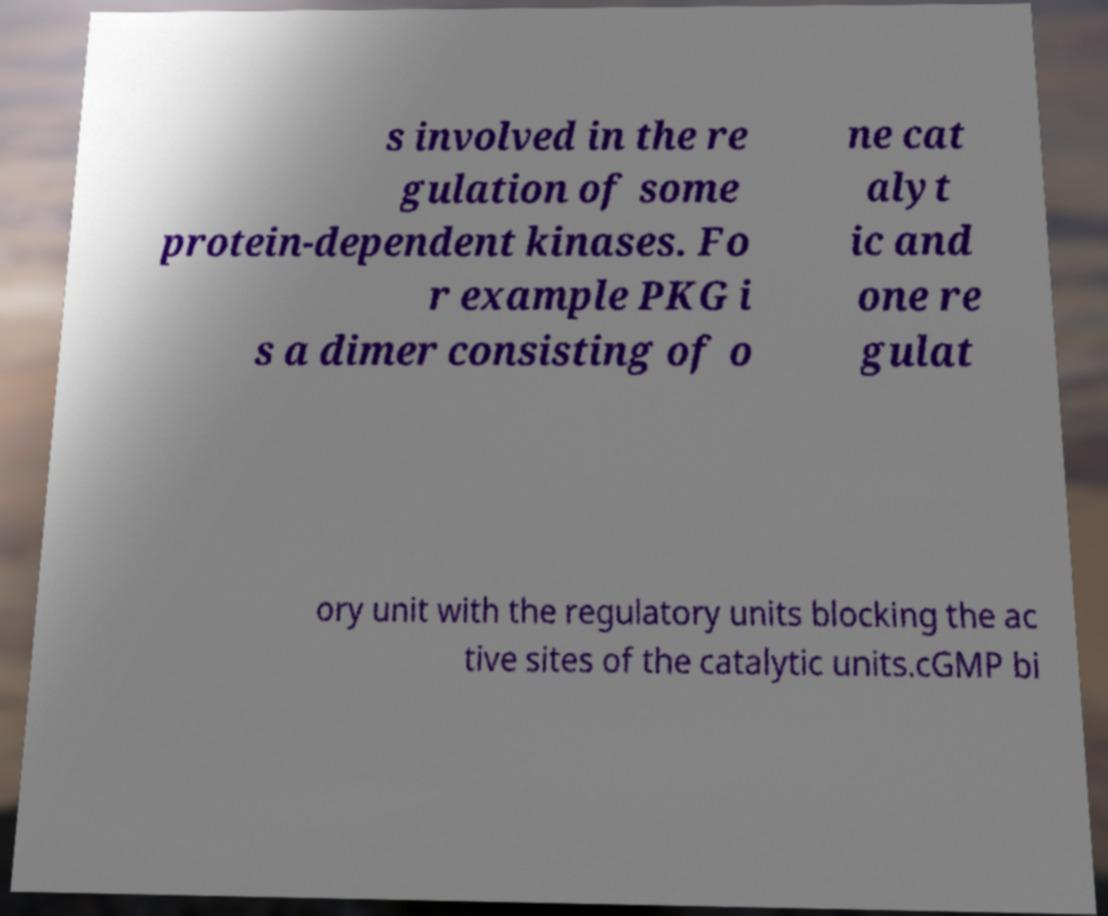For documentation purposes, I need the text within this image transcribed. Could you provide that? s involved in the re gulation of some protein-dependent kinases. Fo r example PKG i s a dimer consisting of o ne cat alyt ic and one re gulat ory unit with the regulatory units blocking the ac tive sites of the catalytic units.cGMP bi 